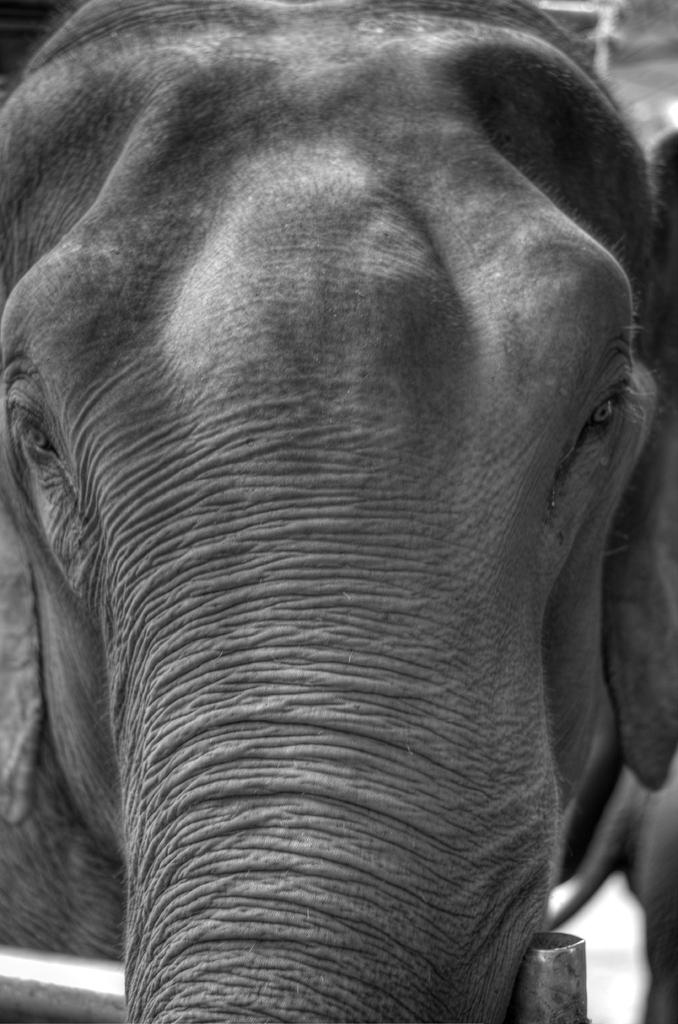What part of an elephant is the focus of the image? There is a close view of an elephant trunk in the image. Can you describe the texture or appearance of the elephant trunk? Unfortunately, the image does not provide enough detail to describe the texture or appearance of the elephant trunk. How many mice can be seen hiding in the cave in the image? There is no cave or mice present in the image; it features a close view of an elephant trunk. 